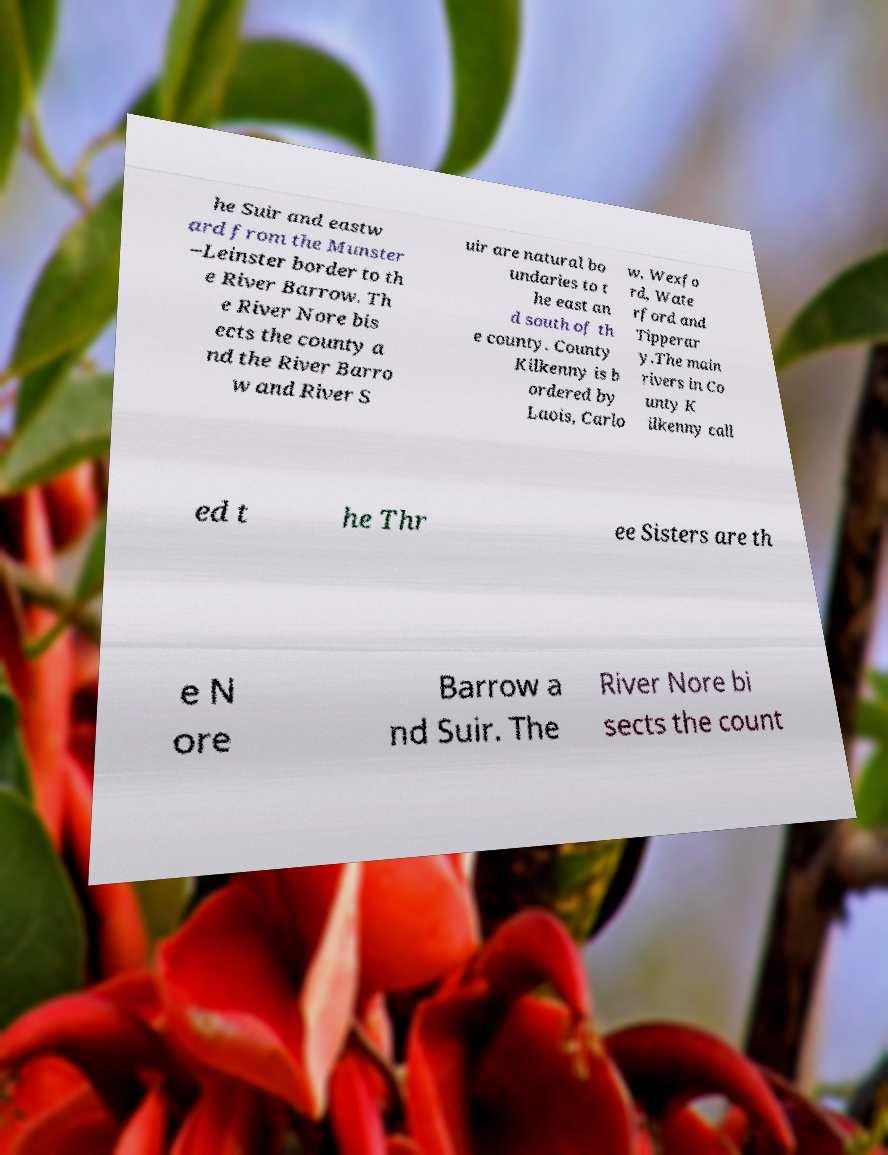Could you extract and type out the text from this image? he Suir and eastw ard from the Munster –Leinster border to th e River Barrow. Th e River Nore bis ects the county a nd the River Barro w and River S uir are natural bo undaries to t he east an d south of th e county. County Kilkenny is b ordered by Laois, Carlo w, Wexfo rd, Wate rford and Tipperar y.The main rivers in Co unty K ilkenny call ed t he Thr ee Sisters are th e N ore Barrow a nd Suir. The River Nore bi sects the count 